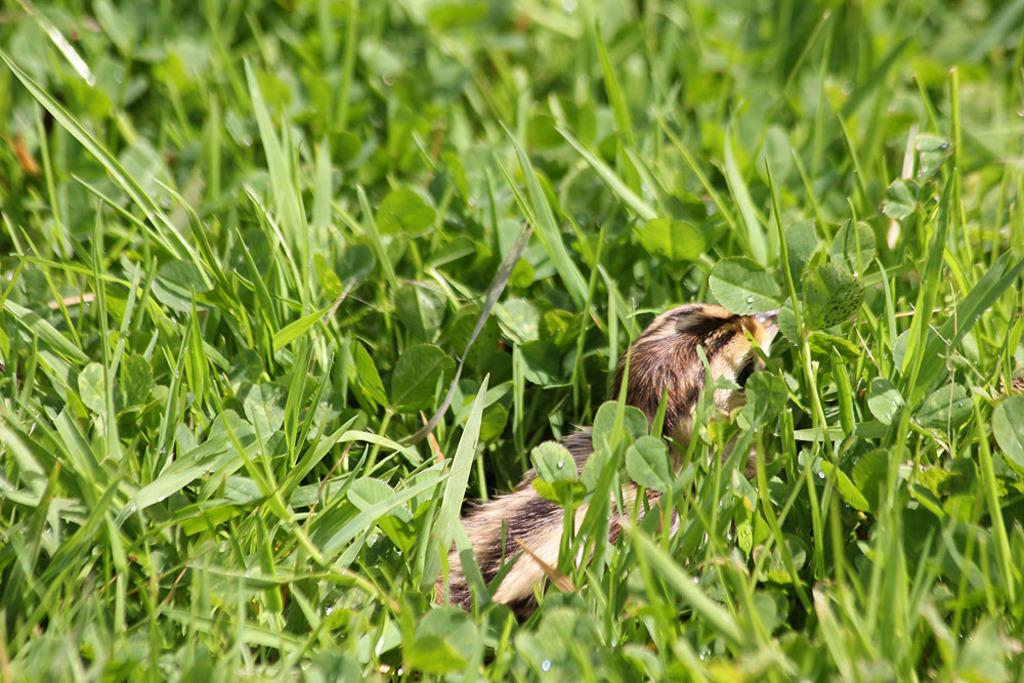What type of living organism can be seen in the plants in the image? There is a bird or an animal in the plants in the image. Can you describe the environment where the bird or animal is located? The bird or animal is located in the plants, which suggests a natural or outdoor setting. What type of tent can be seen in the image? There is no tent present in the image; it features a bird or an animal in the plants. What time of day is depicted in the image? The time of day cannot be determined from the image, as there is no indication of lighting or shadows. 